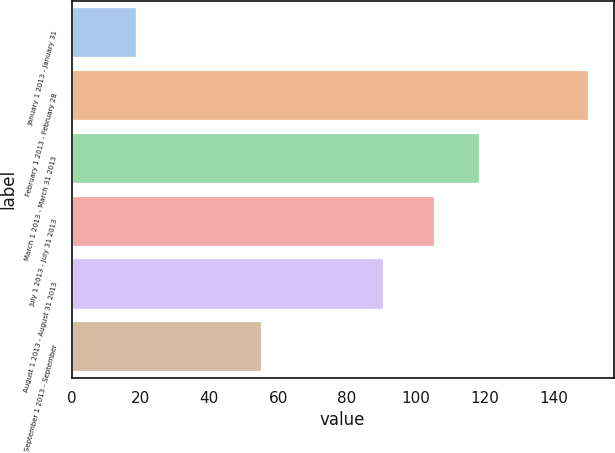<chart> <loc_0><loc_0><loc_500><loc_500><bar_chart><fcel>January 1 2013 - January 31<fcel>February 1 2013 - February 28<fcel>March 1 2013 - March 31 2013<fcel>July 1 2013 - July 31 2013<fcel>August 1 2013 - August 31 2013<fcel>September 1 2013 - September<nl><fcel>18.6<fcel>150<fcel>118.34<fcel>105.2<fcel>90.6<fcel>55<nl></chart> 